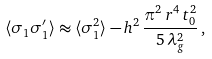Convert formula to latex. <formula><loc_0><loc_0><loc_500><loc_500>\langle \sigma _ { 1 } \sigma ^ { \prime } _ { 1 } \rangle \approx \langle \sigma _ { 1 } ^ { 2 } \rangle - h ^ { 2 } \, \frac { \pi ^ { 2 } \, r ^ { 4 } \, t _ { 0 } ^ { 2 } } { 5 \, \lambda _ { g } ^ { 2 } } \, ,</formula> 